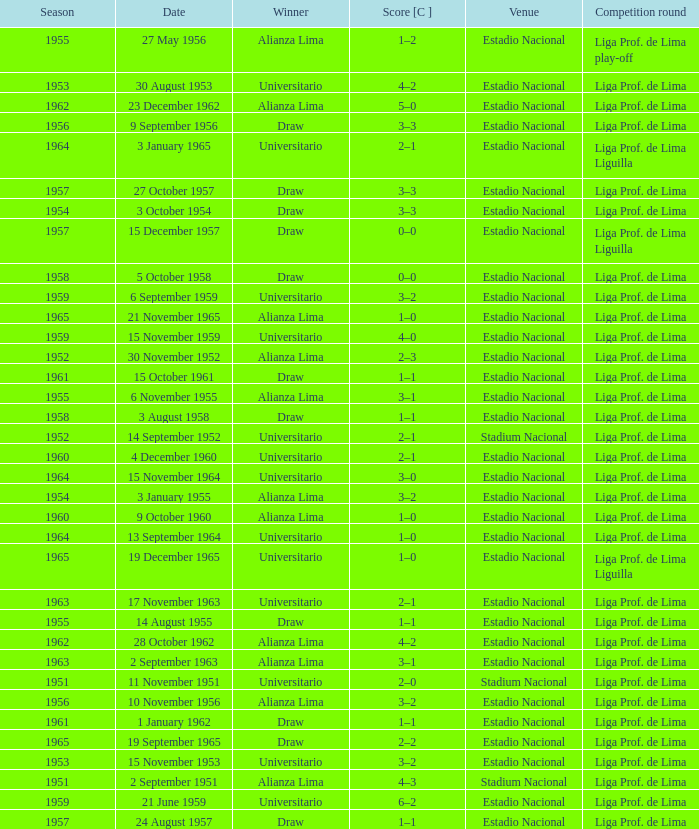What is the most recent season with a date of 27 October 1957? 1957.0. 